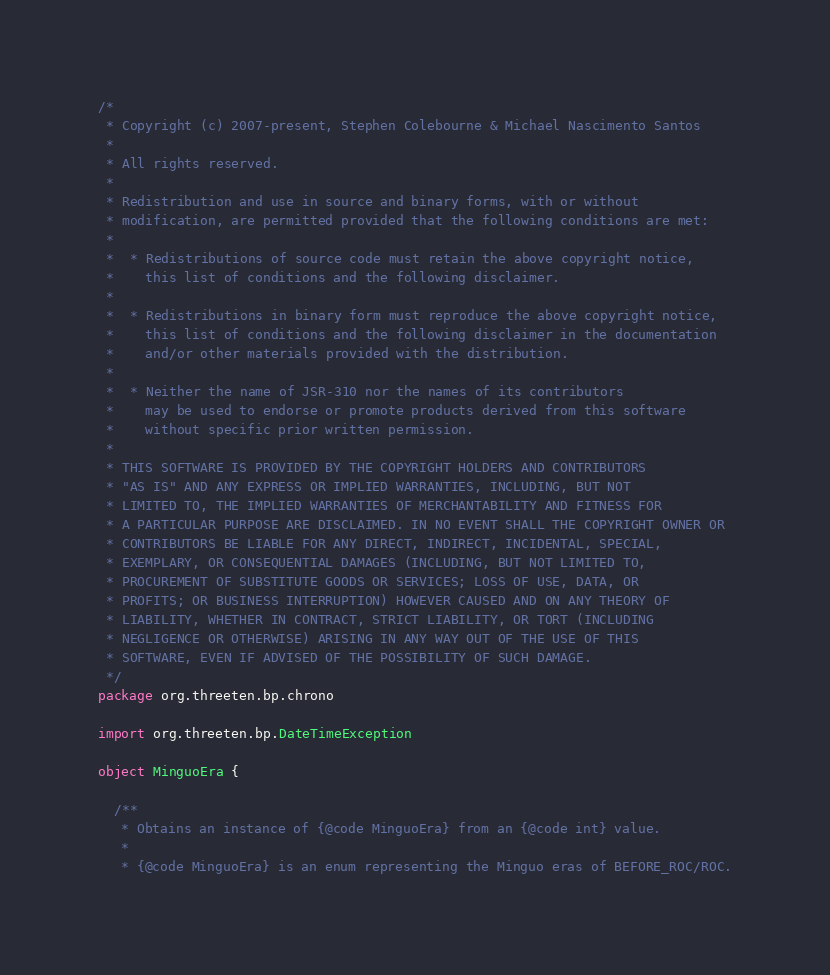Convert code to text. <code><loc_0><loc_0><loc_500><loc_500><_Scala_>/*
 * Copyright (c) 2007-present, Stephen Colebourne & Michael Nascimento Santos
 *
 * All rights reserved.
 *
 * Redistribution and use in source and binary forms, with or without
 * modification, are permitted provided that the following conditions are met:
 *
 *  * Redistributions of source code must retain the above copyright notice,
 *    this list of conditions and the following disclaimer.
 *
 *  * Redistributions in binary form must reproduce the above copyright notice,
 *    this list of conditions and the following disclaimer in the documentation
 *    and/or other materials provided with the distribution.
 *
 *  * Neither the name of JSR-310 nor the names of its contributors
 *    may be used to endorse or promote products derived from this software
 *    without specific prior written permission.
 *
 * THIS SOFTWARE IS PROVIDED BY THE COPYRIGHT HOLDERS AND CONTRIBUTORS
 * "AS IS" AND ANY EXPRESS OR IMPLIED WARRANTIES, INCLUDING, BUT NOT
 * LIMITED TO, THE IMPLIED WARRANTIES OF MERCHANTABILITY AND FITNESS FOR
 * A PARTICULAR PURPOSE ARE DISCLAIMED. IN NO EVENT SHALL THE COPYRIGHT OWNER OR
 * CONTRIBUTORS BE LIABLE FOR ANY DIRECT, INDIRECT, INCIDENTAL, SPECIAL,
 * EXEMPLARY, OR CONSEQUENTIAL DAMAGES (INCLUDING, BUT NOT LIMITED TO,
 * PROCUREMENT OF SUBSTITUTE GOODS OR SERVICES; LOSS OF USE, DATA, OR
 * PROFITS; OR BUSINESS INTERRUPTION) HOWEVER CAUSED AND ON ANY THEORY OF
 * LIABILITY, WHETHER IN CONTRACT, STRICT LIABILITY, OR TORT (INCLUDING
 * NEGLIGENCE OR OTHERWISE) ARISING IN ANY WAY OUT OF THE USE OF THIS
 * SOFTWARE, EVEN IF ADVISED OF THE POSSIBILITY OF SUCH DAMAGE.
 */
package org.threeten.bp.chrono

import org.threeten.bp.DateTimeException

object MinguoEra {

  /**
   * Obtains an instance of {@code MinguoEra} from an {@code int} value.
   *
   * {@code MinguoEra} is an enum representing the Minguo eras of BEFORE_ROC/ROC.</code> 